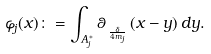Convert formula to latex. <formula><loc_0><loc_0><loc_500><loc_500>\varphi _ { j } ( x ) \colon = \int _ { A _ { j } ^ { \ast } } \theta _ { \, _ { \frac { \delta } { 4 m _ { j } } } } \, ( x - y ) \, d y .</formula> 